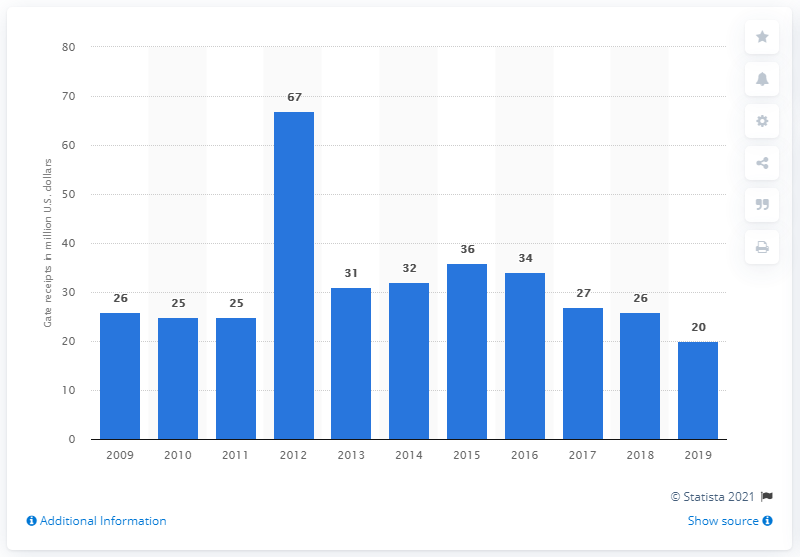Indicate a few pertinent items in this graphic. The gate receipts of the Miami Marlins in 2019 were 20.. The gate receipts of the Miami Marlins in 2019 were 20.. 